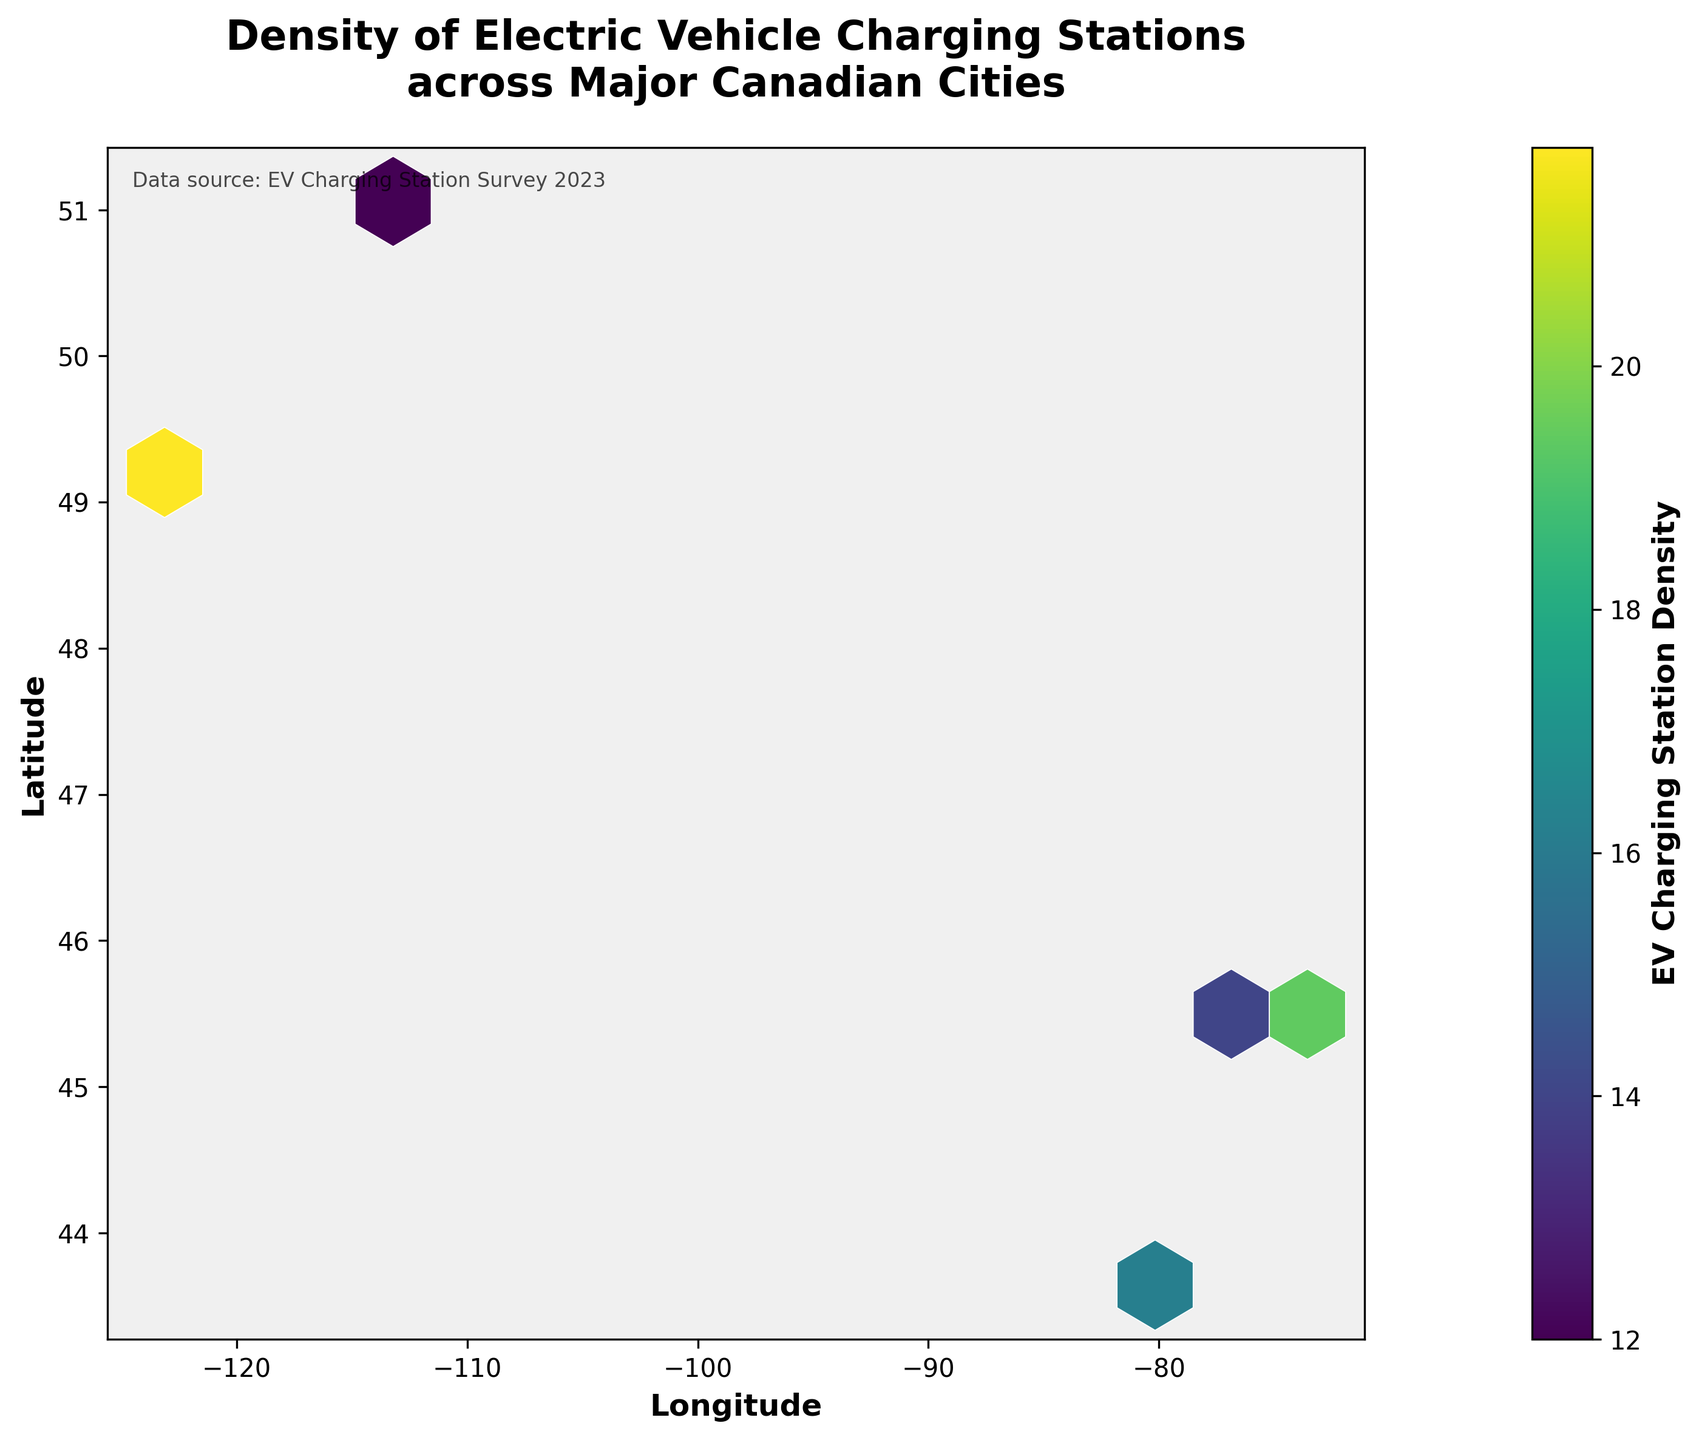What is the title of the hexbin plot? The title is typically found at the top of the figure in bold text. In this plot, it is "Density of Electric Vehicle Charging Stations across Major Canadian Cities".
Answer: Density of Electric Vehicle Charging Stations across Major Canadian Cities What do the colors in the hexbin plot represent? The colors of the hexagons within the plot represent the density of electric vehicle charging stations. Darker colors indicate areas with higher densities, as shown by the color bar labeled "EV Charging Station Density".
Answer: Density of EV Charging Stations What is the range of values shown in the color bar? The color bar is on the right side of the plot and displays the range of densities from the minimum to the maximum value. The range begins at 10 and goes up to 25.
Answer: 10 to 25 Which axis represents latitude? The y-axis represents the latitude, as indicated by the label "Latitude" on the left side of the plot.
Answer: y-axis Which city appears to have the highest density of EV charging stations? By observing the concentrations and color intensity of hexagons, Vancouver (approximately -123 longitude and 49 latitude) exhibits the highest density with values up to 25.
Answer: Vancouver Compare the density of charging stations in Toronto and Montreal. Which one has higher density? The density can be visually compared by examining the color intensity of the hexagons around respective coordinates. Montreal (approximately -73 longitude and 45 latitude) exhibits higher density hexagons compared to Toronto (approximately -79 longitude and 43 latitude).
Answer: Montreal Rank the cities from highest to lowest based on their maximum EV charging station density. We need to observe the highest values depicted by the darkest hexagons for each city. The ranking is: Vancouver (25), Montreal (22), Toronto (20), Ottawa and Calgary (both 16).
Answer: Vancouver, Montreal, Toronto, Ottawa, Calgary Identify the city with the lowest density of EV charging stations. Observing the plot, Calgary (around -114 longitude and 51 latitude) has the lowest density with visible values reaching just up to 14.
Answer: Calgary What is the most common density value range among all cities? By visually estimating the density ranges by the frequency of hexagon colors, the most common density range seems to fall between 15 and 20.
Answer: 15 to 20 Explain how you can identify areas with the highest density of EV charging stations on the plot. Areas with the highest density are represented by hexagons with the darkest colors (according to the viridis color map). These hexagons are concentrated in Vancouver and parts of Montreal.
Answer: Darkest hexagons in Vancouver and Montreal 